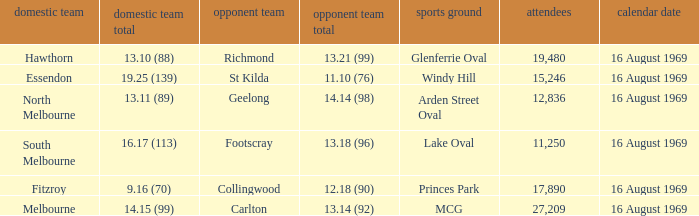What was the away team when the game was at Princes Park? Collingwood. 